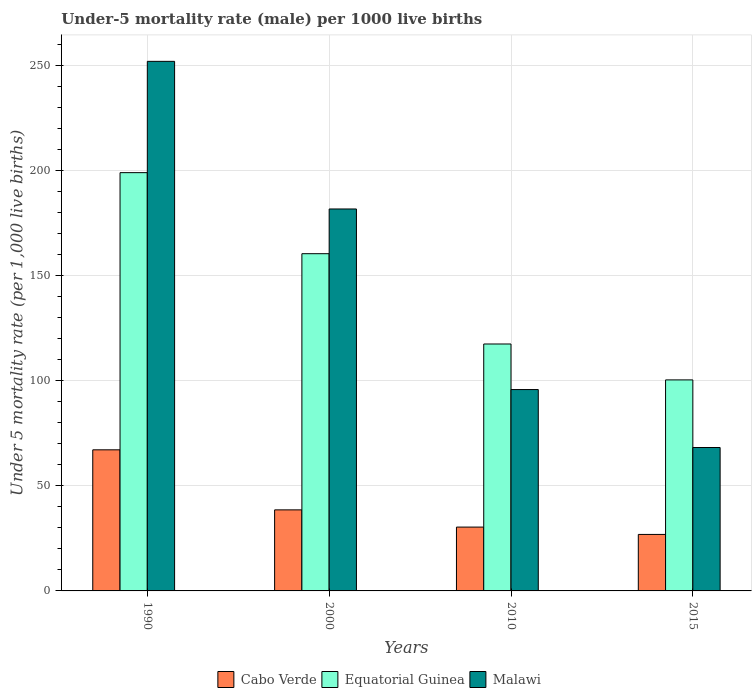Are the number of bars on each tick of the X-axis equal?
Make the answer very short. Yes. How many bars are there on the 3rd tick from the left?
Offer a terse response. 3. How many bars are there on the 3rd tick from the right?
Keep it short and to the point. 3. What is the label of the 3rd group of bars from the left?
Offer a very short reply. 2010. In how many cases, is the number of bars for a given year not equal to the number of legend labels?
Your answer should be very brief. 0. What is the under-five mortality rate in Equatorial Guinea in 2010?
Your answer should be very brief. 117.6. Across all years, what is the maximum under-five mortality rate in Equatorial Guinea?
Keep it short and to the point. 199.2. Across all years, what is the minimum under-five mortality rate in Cabo Verde?
Give a very brief answer. 26.9. In which year was the under-five mortality rate in Equatorial Guinea minimum?
Offer a terse response. 2015. What is the total under-five mortality rate in Equatorial Guinea in the graph?
Provide a succinct answer. 577.9. What is the difference between the under-five mortality rate in Equatorial Guinea in 1990 and that in 2015?
Give a very brief answer. 98.7. What is the difference between the under-five mortality rate in Cabo Verde in 2000 and the under-five mortality rate in Malawi in 2010?
Make the answer very short. -57.3. What is the average under-five mortality rate in Equatorial Guinea per year?
Make the answer very short. 144.47. In the year 2015, what is the difference between the under-five mortality rate in Equatorial Guinea and under-five mortality rate in Cabo Verde?
Your response must be concise. 73.6. What is the ratio of the under-five mortality rate in Malawi in 2000 to that in 2010?
Your answer should be very brief. 1.9. Is the under-five mortality rate in Malawi in 1990 less than that in 2010?
Provide a short and direct response. No. Is the difference between the under-five mortality rate in Equatorial Guinea in 2000 and 2015 greater than the difference between the under-five mortality rate in Cabo Verde in 2000 and 2015?
Offer a terse response. Yes. What is the difference between the highest and the second highest under-five mortality rate in Cabo Verde?
Offer a very short reply. 28.6. What is the difference between the highest and the lowest under-five mortality rate in Cabo Verde?
Ensure brevity in your answer.  40.3. Is the sum of the under-five mortality rate in Equatorial Guinea in 1990 and 2015 greater than the maximum under-five mortality rate in Cabo Verde across all years?
Offer a very short reply. Yes. What does the 2nd bar from the left in 2010 represents?
Provide a succinct answer. Equatorial Guinea. What does the 2nd bar from the right in 2015 represents?
Give a very brief answer. Equatorial Guinea. Is it the case that in every year, the sum of the under-five mortality rate in Equatorial Guinea and under-five mortality rate in Malawi is greater than the under-five mortality rate in Cabo Verde?
Your response must be concise. Yes. How many bars are there?
Ensure brevity in your answer.  12. Are the values on the major ticks of Y-axis written in scientific E-notation?
Provide a succinct answer. No. Does the graph contain any zero values?
Keep it short and to the point. No. Does the graph contain grids?
Offer a terse response. Yes. Where does the legend appear in the graph?
Offer a terse response. Bottom center. How many legend labels are there?
Provide a short and direct response. 3. How are the legend labels stacked?
Provide a short and direct response. Horizontal. What is the title of the graph?
Provide a succinct answer. Under-5 mortality rate (male) per 1000 live births. Does "Jamaica" appear as one of the legend labels in the graph?
Ensure brevity in your answer.  No. What is the label or title of the X-axis?
Keep it short and to the point. Years. What is the label or title of the Y-axis?
Provide a succinct answer. Under 5 mortality rate (per 1,0 live births). What is the Under 5 mortality rate (per 1,000 live births) in Cabo Verde in 1990?
Offer a very short reply. 67.2. What is the Under 5 mortality rate (per 1,000 live births) of Equatorial Guinea in 1990?
Ensure brevity in your answer.  199.2. What is the Under 5 mortality rate (per 1,000 live births) in Malawi in 1990?
Ensure brevity in your answer.  252.2. What is the Under 5 mortality rate (per 1,000 live births) of Cabo Verde in 2000?
Your answer should be compact. 38.6. What is the Under 5 mortality rate (per 1,000 live births) of Equatorial Guinea in 2000?
Offer a very short reply. 160.6. What is the Under 5 mortality rate (per 1,000 live births) of Malawi in 2000?
Offer a very short reply. 181.9. What is the Under 5 mortality rate (per 1,000 live births) in Cabo Verde in 2010?
Your answer should be very brief. 30.4. What is the Under 5 mortality rate (per 1,000 live births) of Equatorial Guinea in 2010?
Your answer should be compact. 117.6. What is the Under 5 mortality rate (per 1,000 live births) in Malawi in 2010?
Offer a terse response. 95.9. What is the Under 5 mortality rate (per 1,000 live births) of Cabo Verde in 2015?
Make the answer very short. 26.9. What is the Under 5 mortality rate (per 1,000 live births) in Equatorial Guinea in 2015?
Offer a very short reply. 100.5. What is the Under 5 mortality rate (per 1,000 live births) in Malawi in 2015?
Provide a succinct answer. 68.3. Across all years, what is the maximum Under 5 mortality rate (per 1,000 live births) in Cabo Verde?
Ensure brevity in your answer.  67.2. Across all years, what is the maximum Under 5 mortality rate (per 1,000 live births) of Equatorial Guinea?
Provide a succinct answer. 199.2. Across all years, what is the maximum Under 5 mortality rate (per 1,000 live births) in Malawi?
Make the answer very short. 252.2. Across all years, what is the minimum Under 5 mortality rate (per 1,000 live births) of Cabo Verde?
Make the answer very short. 26.9. Across all years, what is the minimum Under 5 mortality rate (per 1,000 live births) of Equatorial Guinea?
Make the answer very short. 100.5. Across all years, what is the minimum Under 5 mortality rate (per 1,000 live births) in Malawi?
Your answer should be very brief. 68.3. What is the total Under 5 mortality rate (per 1,000 live births) in Cabo Verde in the graph?
Offer a very short reply. 163.1. What is the total Under 5 mortality rate (per 1,000 live births) of Equatorial Guinea in the graph?
Make the answer very short. 577.9. What is the total Under 5 mortality rate (per 1,000 live births) in Malawi in the graph?
Provide a succinct answer. 598.3. What is the difference between the Under 5 mortality rate (per 1,000 live births) of Cabo Verde in 1990 and that in 2000?
Provide a short and direct response. 28.6. What is the difference between the Under 5 mortality rate (per 1,000 live births) of Equatorial Guinea in 1990 and that in 2000?
Your answer should be compact. 38.6. What is the difference between the Under 5 mortality rate (per 1,000 live births) in Malawi in 1990 and that in 2000?
Your answer should be compact. 70.3. What is the difference between the Under 5 mortality rate (per 1,000 live births) in Cabo Verde in 1990 and that in 2010?
Offer a terse response. 36.8. What is the difference between the Under 5 mortality rate (per 1,000 live births) in Equatorial Guinea in 1990 and that in 2010?
Offer a terse response. 81.6. What is the difference between the Under 5 mortality rate (per 1,000 live births) of Malawi in 1990 and that in 2010?
Your answer should be very brief. 156.3. What is the difference between the Under 5 mortality rate (per 1,000 live births) in Cabo Verde in 1990 and that in 2015?
Give a very brief answer. 40.3. What is the difference between the Under 5 mortality rate (per 1,000 live births) in Equatorial Guinea in 1990 and that in 2015?
Provide a short and direct response. 98.7. What is the difference between the Under 5 mortality rate (per 1,000 live births) of Malawi in 1990 and that in 2015?
Give a very brief answer. 183.9. What is the difference between the Under 5 mortality rate (per 1,000 live births) of Equatorial Guinea in 2000 and that in 2010?
Provide a succinct answer. 43. What is the difference between the Under 5 mortality rate (per 1,000 live births) of Malawi in 2000 and that in 2010?
Ensure brevity in your answer.  86. What is the difference between the Under 5 mortality rate (per 1,000 live births) in Equatorial Guinea in 2000 and that in 2015?
Your answer should be compact. 60.1. What is the difference between the Under 5 mortality rate (per 1,000 live births) in Malawi in 2000 and that in 2015?
Ensure brevity in your answer.  113.6. What is the difference between the Under 5 mortality rate (per 1,000 live births) in Cabo Verde in 2010 and that in 2015?
Ensure brevity in your answer.  3.5. What is the difference between the Under 5 mortality rate (per 1,000 live births) in Equatorial Guinea in 2010 and that in 2015?
Your answer should be compact. 17.1. What is the difference between the Under 5 mortality rate (per 1,000 live births) of Malawi in 2010 and that in 2015?
Give a very brief answer. 27.6. What is the difference between the Under 5 mortality rate (per 1,000 live births) of Cabo Verde in 1990 and the Under 5 mortality rate (per 1,000 live births) of Equatorial Guinea in 2000?
Ensure brevity in your answer.  -93.4. What is the difference between the Under 5 mortality rate (per 1,000 live births) of Cabo Verde in 1990 and the Under 5 mortality rate (per 1,000 live births) of Malawi in 2000?
Your answer should be very brief. -114.7. What is the difference between the Under 5 mortality rate (per 1,000 live births) of Cabo Verde in 1990 and the Under 5 mortality rate (per 1,000 live births) of Equatorial Guinea in 2010?
Provide a succinct answer. -50.4. What is the difference between the Under 5 mortality rate (per 1,000 live births) in Cabo Verde in 1990 and the Under 5 mortality rate (per 1,000 live births) in Malawi in 2010?
Provide a short and direct response. -28.7. What is the difference between the Under 5 mortality rate (per 1,000 live births) of Equatorial Guinea in 1990 and the Under 5 mortality rate (per 1,000 live births) of Malawi in 2010?
Provide a succinct answer. 103.3. What is the difference between the Under 5 mortality rate (per 1,000 live births) in Cabo Verde in 1990 and the Under 5 mortality rate (per 1,000 live births) in Equatorial Guinea in 2015?
Offer a terse response. -33.3. What is the difference between the Under 5 mortality rate (per 1,000 live births) in Equatorial Guinea in 1990 and the Under 5 mortality rate (per 1,000 live births) in Malawi in 2015?
Your response must be concise. 130.9. What is the difference between the Under 5 mortality rate (per 1,000 live births) of Cabo Verde in 2000 and the Under 5 mortality rate (per 1,000 live births) of Equatorial Guinea in 2010?
Your answer should be very brief. -79. What is the difference between the Under 5 mortality rate (per 1,000 live births) in Cabo Verde in 2000 and the Under 5 mortality rate (per 1,000 live births) in Malawi in 2010?
Your answer should be very brief. -57.3. What is the difference between the Under 5 mortality rate (per 1,000 live births) of Equatorial Guinea in 2000 and the Under 5 mortality rate (per 1,000 live births) of Malawi in 2010?
Your answer should be compact. 64.7. What is the difference between the Under 5 mortality rate (per 1,000 live births) in Cabo Verde in 2000 and the Under 5 mortality rate (per 1,000 live births) in Equatorial Guinea in 2015?
Provide a succinct answer. -61.9. What is the difference between the Under 5 mortality rate (per 1,000 live births) of Cabo Verde in 2000 and the Under 5 mortality rate (per 1,000 live births) of Malawi in 2015?
Provide a short and direct response. -29.7. What is the difference between the Under 5 mortality rate (per 1,000 live births) of Equatorial Guinea in 2000 and the Under 5 mortality rate (per 1,000 live births) of Malawi in 2015?
Provide a short and direct response. 92.3. What is the difference between the Under 5 mortality rate (per 1,000 live births) in Cabo Verde in 2010 and the Under 5 mortality rate (per 1,000 live births) in Equatorial Guinea in 2015?
Offer a terse response. -70.1. What is the difference between the Under 5 mortality rate (per 1,000 live births) of Cabo Verde in 2010 and the Under 5 mortality rate (per 1,000 live births) of Malawi in 2015?
Give a very brief answer. -37.9. What is the difference between the Under 5 mortality rate (per 1,000 live births) of Equatorial Guinea in 2010 and the Under 5 mortality rate (per 1,000 live births) of Malawi in 2015?
Offer a terse response. 49.3. What is the average Under 5 mortality rate (per 1,000 live births) in Cabo Verde per year?
Provide a succinct answer. 40.77. What is the average Under 5 mortality rate (per 1,000 live births) of Equatorial Guinea per year?
Make the answer very short. 144.47. What is the average Under 5 mortality rate (per 1,000 live births) of Malawi per year?
Ensure brevity in your answer.  149.57. In the year 1990, what is the difference between the Under 5 mortality rate (per 1,000 live births) in Cabo Verde and Under 5 mortality rate (per 1,000 live births) in Equatorial Guinea?
Offer a very short reply. -132. In the year 1990, what is the difference between the Under 5 mortality rate (per 1,000 live births) in Cabo Verde and Under 5 mortality rate (per 1,000 live births) in Malawi?
Give a very brief answer. -185. In the year 1990, what is the difference between the Under 5 mortality rate (per 1,000 live births) in Equatorial Guinea and Under 5 mortality rate (per 1,000 live births) in Malawi?
Offer a terse response. -53. In the year 2000, what is the difference between the Under 5 mortality rate (per 1,000 live births) of Cabo Verde and Under 5 mortality rate (per 1,000 live births) of Equatorial Guinea?
Ensure brevity in your answer.  -122. In the year 2000, what is the difference between the Under 5 mortality rate (per 1,000 live births) of Cabo Verde and Under 5 mortality rate (per 1,000 live births) of Malawi?
Your response must be concise. -143.3. In the year 2000, what is the difference between the Under 5 mortality rate (per 1,000 live births) of Equatorial Guinea and Under 5 mortality rate (per 1,000 live births) of Malawi?
Offer a very short reply. -21.3. In the year 2010, what is the difference between the Under 5 mortality rate (per 1,000 live births) in Cabo Verde and Under 5 mortality rate (per 1,000 live births) in Equatorial Guinea?
Provide a succinct answer. -87.2. In the year 2010, what is the difference between the Under 5 mortality rate (per 1,000 live births) of Cabo Verde and Under 5 mortality rate (per 1,000 live births) of Malawi?
Your response must be concise. -65.5. In the year 2010, what is the difference between the Under 5 mortality rate (per 1,000 live births) of Equatorial Guinea and Under 5 mortality rate (per 1,000 live births) of Malawi?
Offer a very short reply. 21.7. In the year 2015, what is the difference between the Under 5 mortality rate (per 1,000 live births) of Cabo Verde and Under 5 mortality rate (per 1,000 live births) of Equatorial Guinea?
Offer a very short reply. -73.6. In the year 2015, what is the difference between the Under 5 mortality rate (per 1,000 live births) in Cabo Verde and Under 5 mortality rate (per 1,000 live births) in Malawi?
Provide a short and direct response. -41.4. In the year 2015, what is the difference between the Under 5 mortality rate (per 1,000 live births) in Equatorial Guinea and Under 5 mortality rate (per 1,000 live births) in Malawi?
Make the answer very short. 32.2. What is the ratio of the Under 5 mortality rate (per 1,000 live births) in Cabo Verde in 1990 to that in 2000?
Provide a succinct answer. 1.74. What is the ratio of the Under 5 mortality rate (per 1,000 live births) of Equatorial Guinea in 1990 to that in 2000?
Your response must be concise. 1.24. What is the ratio of the Under 5 mortality rate (per 1,000 live births) in Malawi in 1990 to that in 2000?
Make the answer very short. 1.39. What is the ratio of the Under 5 mortality rate (per 1,000 live births) of Cabo Verde in 1990 to that in 2010?
Keep it short and to the point. 2.21. What is the ratio of the Under 5 mortality rate (per 1,000 live births) of Equatorial Guinea in 1990 to that in 2010?
Offer a very short reply. 1.69. What is the ratio of the Under 5 mortality rate (per 1,000 live births) of Malawi in 1990 to that in 2010?
Give a very brief answer. 2.63. What is the ratio of the Under 5 mortality rate (per 1,000 live births) in Cabo Verde in 1990 to that in 2015?
Your answer should be compact. 2.5. What is the ratio of the Under 5 mortality rate (per 1,000 live births) in Equatorial Guinea in 1990 to that in 2015?
Your answer should be very brief. 1.98. What is the ratio of the Under 5 mortality rate (per 1,000 live births) of Malawi in 1990 to that in 2015?
Offer a very short reply. 3.69. What is the ratio of the Under 5 mortality rate (per 1,000 live births) in Cabo Verde in 2000 to that in 2010?
Ensure brevity in your answer.  1.27. What is the ratio of the Under 5 mortality rate (per 1,000 live births) of Equatorial Guinea in 2000 to that in 2010?
Your answer should be very brief. 1.37. What is the ratio of the Under 5 mortality rate (per 1,000 live births) of Malawi in 2000 to that in 2010?
Offer a very short reply. 1.9. What is the ratio of the Under 5 mortality rate (per 1,000 live births) in Cabo Verde in 2000 to that in 2015?
Provide a short and direct response. 1.43. What is the ratio of the Under 5 mortality rate (per 1,000 live births) of Equatorial Guinea in 2000 to that in 2015?
Keep it short and to the point. 1.6. What is the ratio of the Under 5 mortality rate (per 1,000 live births) in Malawi in 2000 to that in 2015?
Keep it short and to the point. 2.66. What is the ratio of the Under 5 mortality rate (per 1,000 live births) of Cabo Verde in 2010 to that in 2015?
Offer a very short reply. 1.13. What is the ratio of the Under 5 mortality rate (per 1,000 live births) in Equatorial Guinea in 2010 to that in 2015?
Ensure brevity in your answer.  1.17. What is the ratio of the Under 5 mortality rate (per 1,000 live births) in Malawi in 2010 to that in 2015?
Your answer should be compact. 1.4. What is the difference between the highest and the second highest Under 5 mortality rate (per 1,000 live births) of Cabo Verde?
Make the answer very short. 28.6. What is the difference between the highest and the second highest Under 5 mortality rate (per 1,000 live births) of Equatorial Guinea?
Offer a terse response. 38.6. What is the difference between the highest and the second highest Under 5 mortality rate (per 1,000 live births) in Malawi?
Your answer should be very brief. 70.3. What is the difference between the highest and the lowest Under 5 mortality rate (per 1,000 live births) in Cabo Verde?
Your response must be concise. 40.3. What is the difference between the highest and the lowest Under 5 mortality rate (per 1,000 live births) of Equatorial Guinea?
Give a very brief answer. 98.7. What is the difference between the highest and the lowest Under 5 mortality rate (per 1,000 live births) of Malawi?
Ensure brevity in your answer.  183.9. 